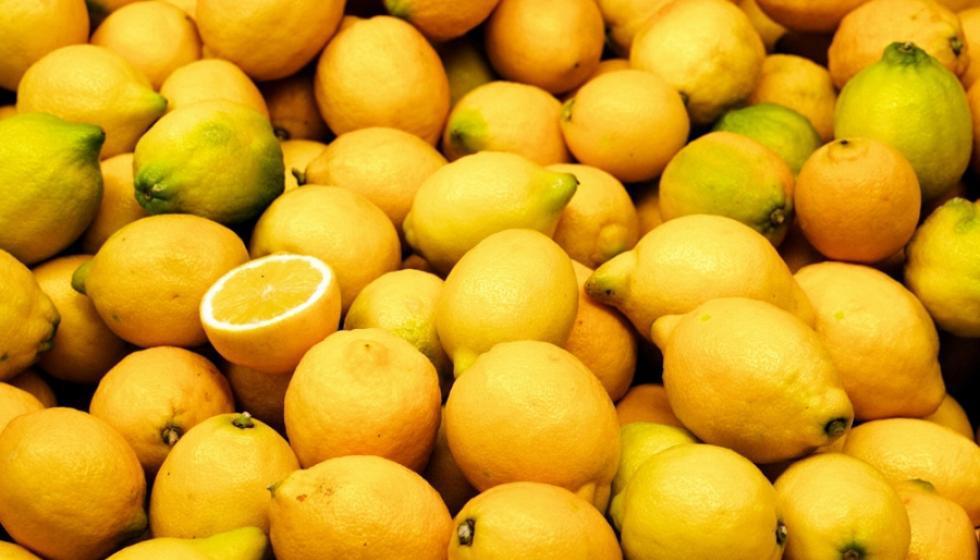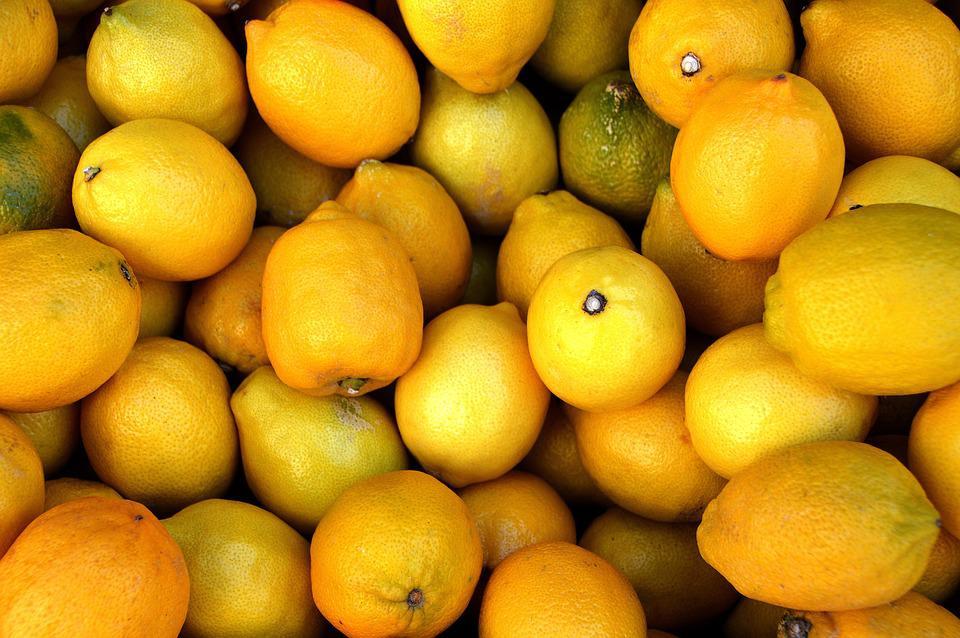The first image is the image on the left, the second image is the image on the right. Examine the images to the left and right. Is the description "The left image depicts a cut lemon half in front of a whole lemon and green leaves and include an upright product container, and the right image contains a mass of whole lemons only." accurate? Answer yes or no. No. The first image is the image on the left, the second image is the image on the right. Given the left and right images, does the statement "There is a real sliced lemon in the left image." hold true? Answer yes or no. Yes. 